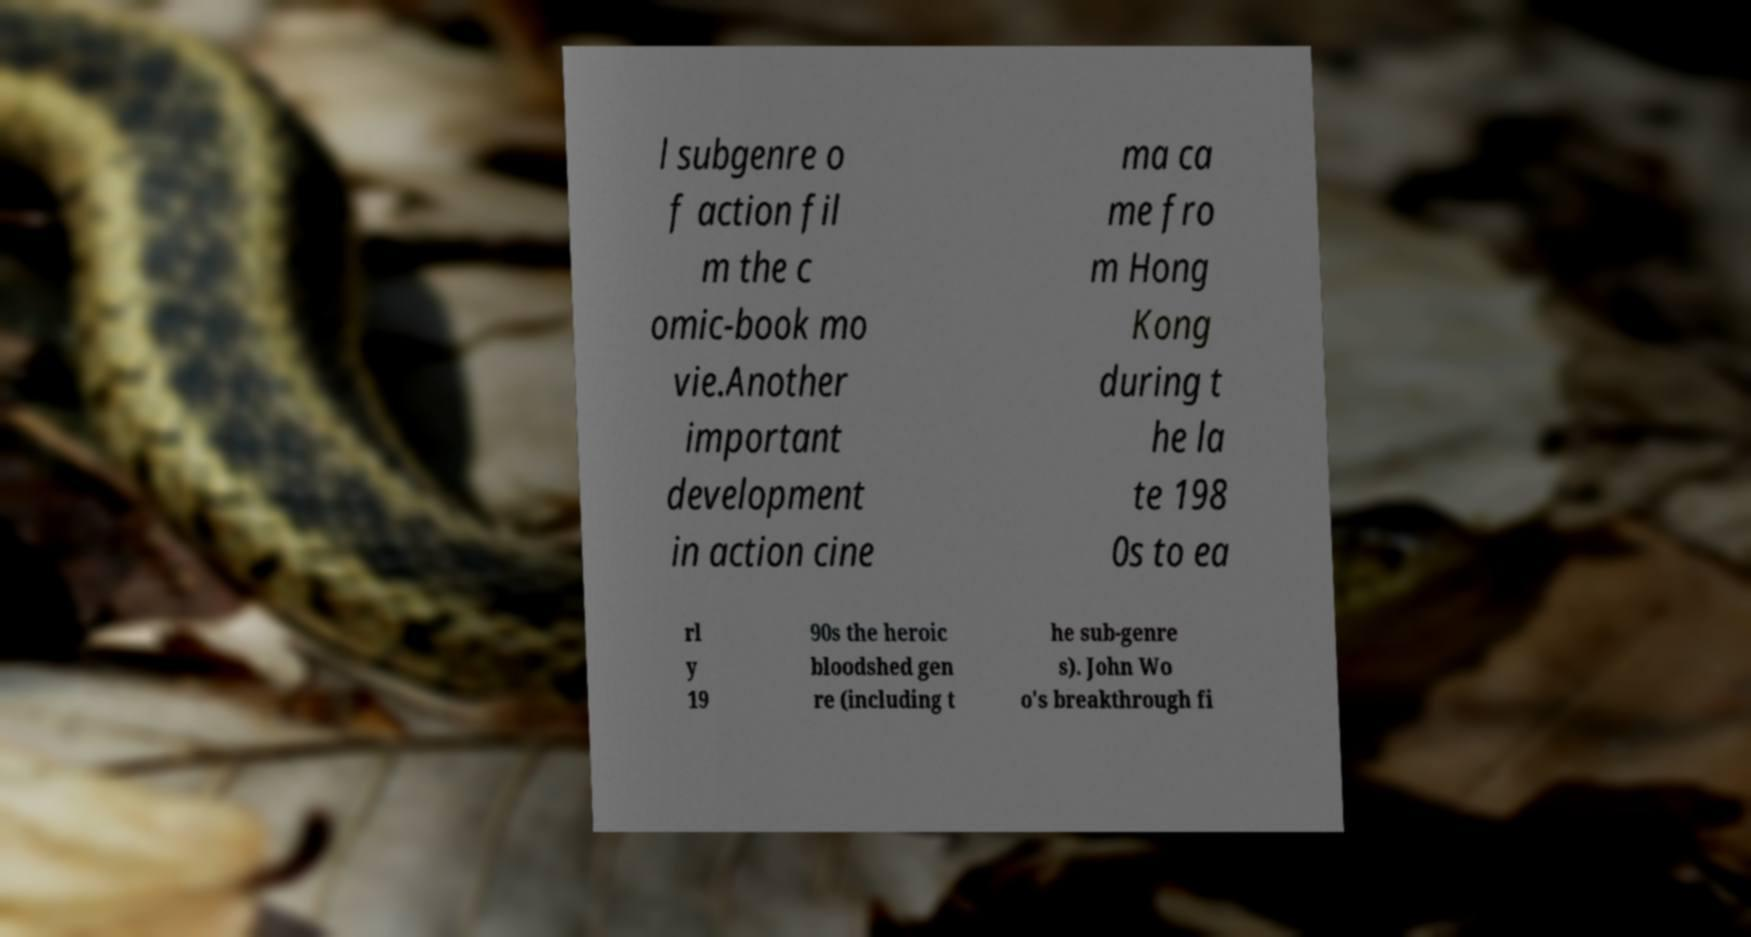Can you read and provide the text displayed in the image?This photo seems to have some interesting text. Can you extract and type it out for me? l subgenre o f action fil m the c omic-book mo vie.Another important development in action cine ma ca me fro m Hong Kong during t he la te 198 0s to ea rl y 19 90s the heroic bloodshed gen re (including t he sub-genre s). John Wo o's breakthrough fi 